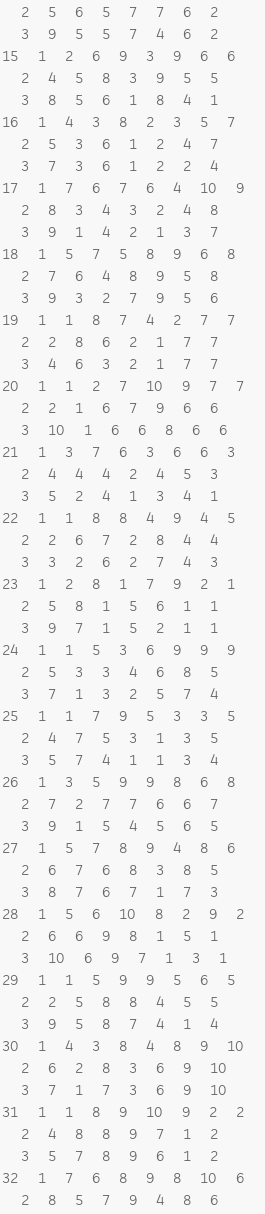Convert code to text. <code><loc_0><loc_0><loc_500><loc_500><_ObjectiveC_>	2	5	6	5	7	7	6	2	
	3	9	5	5	7	4	6	2	
15	1	2	6	9	3	9	6	6	
	2	4	5	8	3	9	5	5	
	3	8	5	6	1	8	4	1	
16	1	4	3	8	2	3	5	7	
	2	5	3	6	1	2	4	7	
	3	7	3	6	1	2	2	4	
17	1	7	6	7	6	4	10	9	
	2	8	3	4	3	2	4	8	
	3	9	1	4	2	1	3	7	
18	1	5	7	5	8	9	6	8	
	2	7	6	4	8	9	5	8	
	3	9	3	2	7	9	5	6	
19	1	1	8	7	4	2	7	7	
	2	2	8	6	2	1	7	7	
	3	4	6	3	2	1	7	7	
20	1	1	2	7	10	9	7	7	
	2	2	1	6	7	9	6	6	
	3	10	1	6	6	8	6	6	
21	1	3	7	6	3	6	6	3	
	2	4	4	4	2	4	5	3	
	3	5	2	4	1	3	4	1	
22	1	1	8	8	4	9	4	5	
	2	2	6	7	2	8	4	4	
	3	3	2	6	2	7	4	3	
23	1	2	8	1	7	9	2	1	
	2	5	8	1	5	6	1	1	
	3	9	7	1	5	2	1	1	
24	1	1	5	3	6	9	9	9	
	2	5	3	3	4	6	8	5	
	3	7	1	3	2	5	7	4	
25	1	1	7	9	5	3	3	5	
	2	4	7	5	3	1	3	5	
	3	5	7	4	1	1	3	4	
26	1	3	5	9	9	8	6	8	
	2	7	2	7	7	6	6	7	
	3	9	1	5	4	5	6	5	
27	1	5	7	8	9	4	8	6	
	2	6	7	6	8	3	8	5	
	3	8	7	6	7	1	7	3	
28	1	5	6	10	8	2	9	2	
	2	6	6	9	8	1	5	1	
	3	10	6	9	7	1	3	1	
29	1	1	5	9	9	5	6	5	
	2	2	5	8	8	4	5	5	
	3	9	5	8	7	4	1	4	
30	1	4	3	8	4	8	9	10	
	2	6	2	8	3	6	9	10	
	3	7	1	7	3	6	9	10	
31	1	1	8	9	10	9	2	2	
	2	4	8	8	9	7	1	2	
	3	5	7	8	9	6	1	2	
32	1	7	6	8	9	8	10	6	
	2	8	5	7	9	4	8	6	</code> 